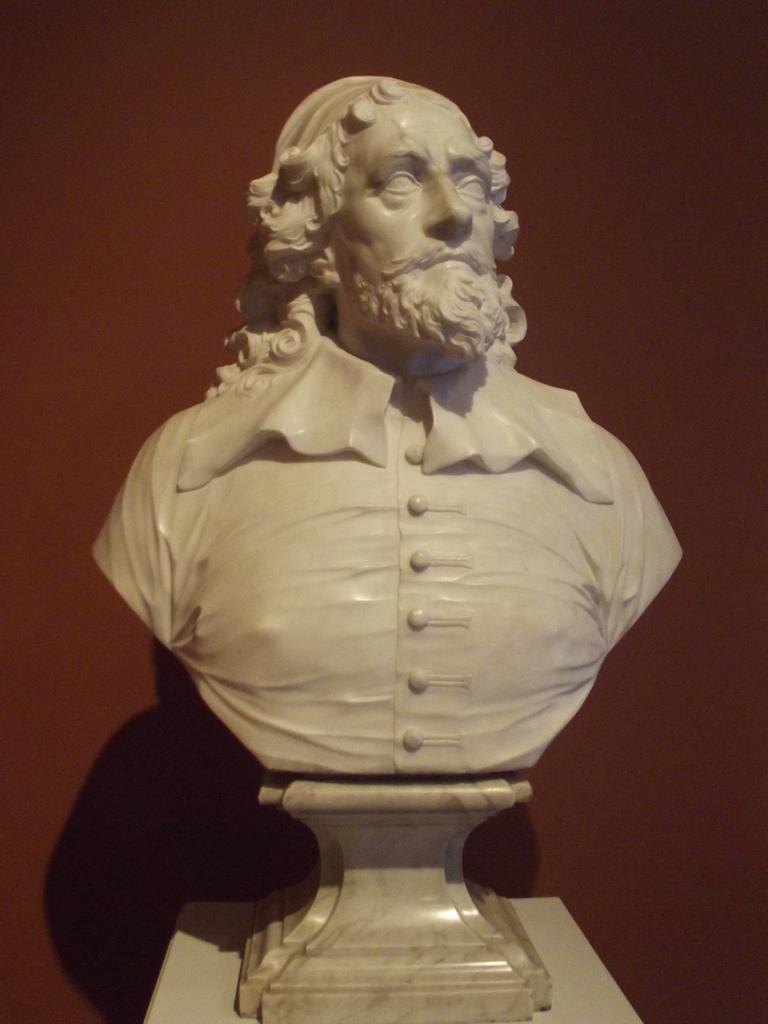What is the main subject of the image? There is a person's sculpture in the image. What can be seen in the background of the image? There is a wall in the image. Can you describe the setting where the image might have been taken? The image may have been taken in a hall. How many girls are present in the image? There are no girls present in the image; it features a person's sculpture and a wall. What type of ring is the sister wearing in the image? There is no sister or ring present in the image. 